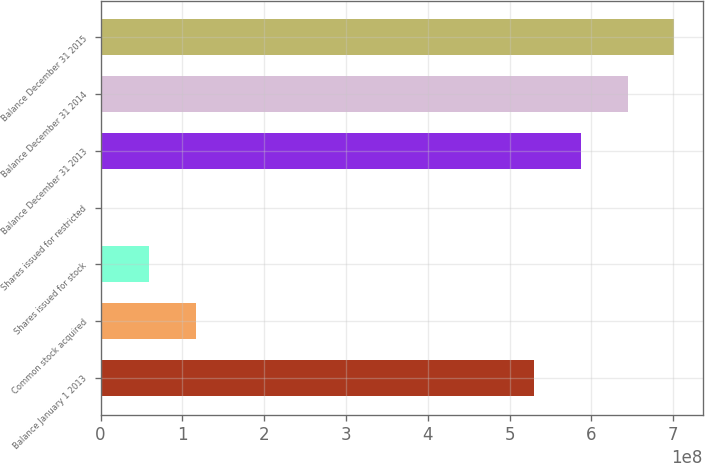Convert chart to OTSL. <chart><loc_0><loc_0><loc_500><loc_500><bar_chart><fcel>Balance January 1 2013<fcel>Common stock acquired<fcel>Shares issued for stock<fcel>Shares issued for restricted<fcel>Balance December 31 2013<fcel>Balance December 31 2014<fcel>Balance December 31 2015<nl><fcel>5.29978e+08<fcel>1.16119e+08<fcel>5.90134e+07<fcel>1.90738e+06<fcel>5.87084e+08<fcel>6.4419e+08<fcel>7.01296e+08<nl></chart> 